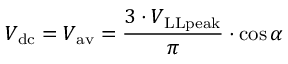<formula> <loc_0><loc_0><loc_500><loc_500>V _ { d c } = V _ { a v } = { \frac { 3 \cdot V _ { L L p e a k } } { \pi } } \cdot \cos \alpha</formula> 